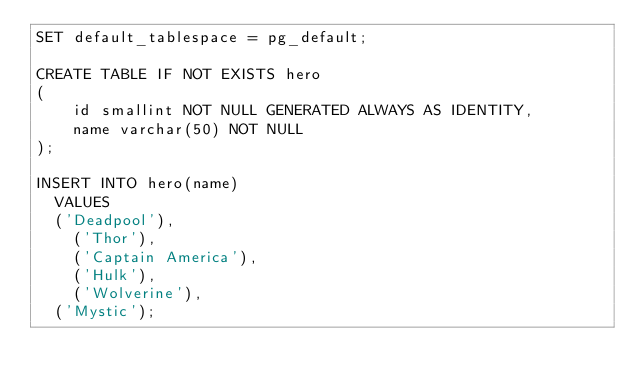Convert code to text. <code><loc_0><loc_0><loc_500><loc_500><_SQL_>SET default_tablespace = pg_default;

CREATE TABLE IF NOT EXISTS hero
(
    id smallint NOT NULL GENERATED ALWAYS AS IDENTITY,
    name varchar(50) NOT NULL
);

INSERT INTO hero(name)
	VALUES 
	('Deadpool'),
    ('Thor'),
    ('Captain America'),
    ('Hulk'),
    ('Wolverine'),
	('Mystic');
</code> 